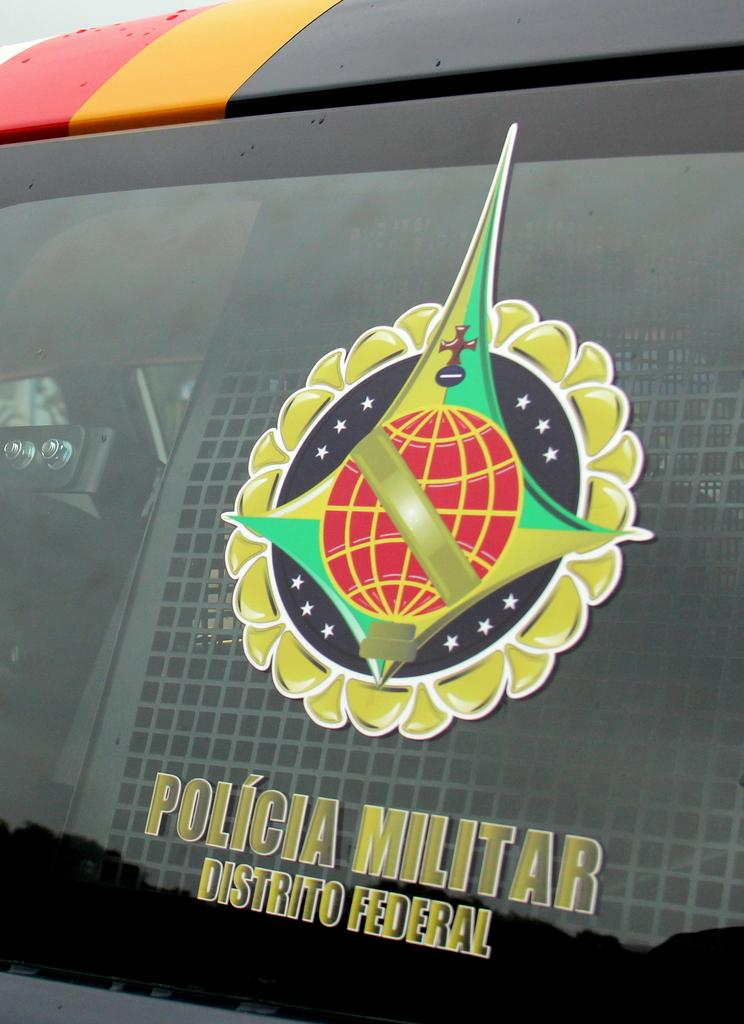<image>
Provide a brief description of the given image. A window says policia militar on it with a picture. 